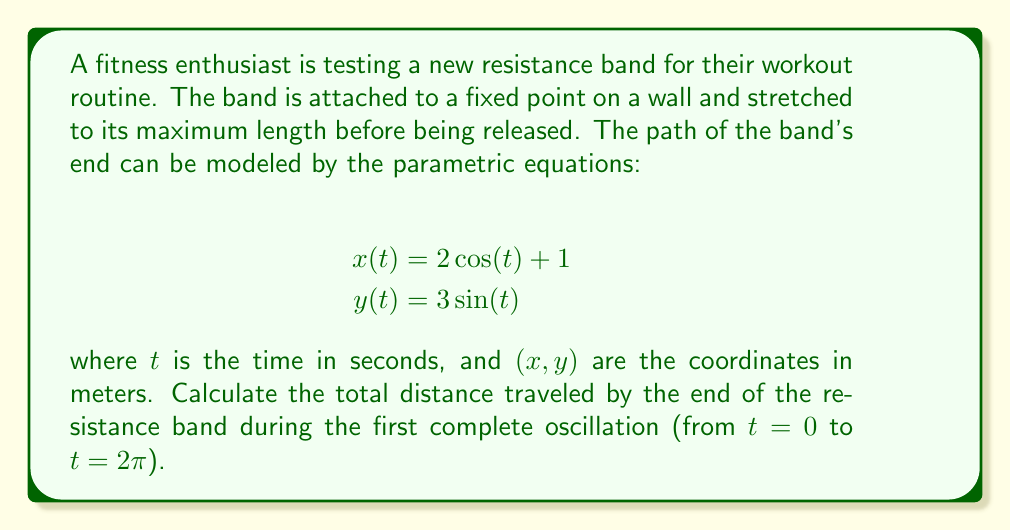Solve this math problem. To solve this problem, we need to follow these steps:

1) The path of the resistance band's end is described by a parametric curve. To find the length of this curve, we need to use the arc length formula for parametric equations:

   $$L = \int_a^b \sqrt{\left(\frac{dx}{dt}\right)^2 + \left(\frac{dy}{dt}\right)^2} dt$$

2) First, let's find $\frac{dx}{dt}$ and $\frac{dy}{dt}$:
   
   $$\frac{dx}{dt} = -2\sin(t)$$
   $$\frac{dy}{dt} = 3\cos(t)$$

3) Now, let's substitute these into our arc length formula:

   $$L = \int_0^{2\pi} \sqrt{(-2\sin(t))^2 + (3\cos(t))^2} dt$$

4) Simplify under the square root:

   $$L = \int_0^{2\pi} \sqrt{4\sin^2(t) + 9\cos^2(t)} dt$$

5) We can factor out a 4 from under the square root:

   $$L = \int_0^{2\pi} 2\sqrt{\sin^2(t) + \frac{9}{4}\cos^2(t)} dt$$

6) Now, we can use the trigonometric identity $\sin^2(t) + \cos^2(t) = 1$ to simplify further:

   $$L = \int_0^{2\pi} 2\sqrt{1 + \frac{5}{4}\cos^2(t)} dt$$

7) This integral doesn't have an elementary antiderivative. We need to use numerical methods or special functions to evaluate it. Using a numerical integration method, we find:

   $$L \approx 15.8649$$

Therefore, the total distance traveled by the end of the resistance band during one complete oscillation is approximately 15.8649 meters.
Answer: The total distance traveled by the end of the resistance band during the first complete oscillation is approximately 15.8649 meters. 